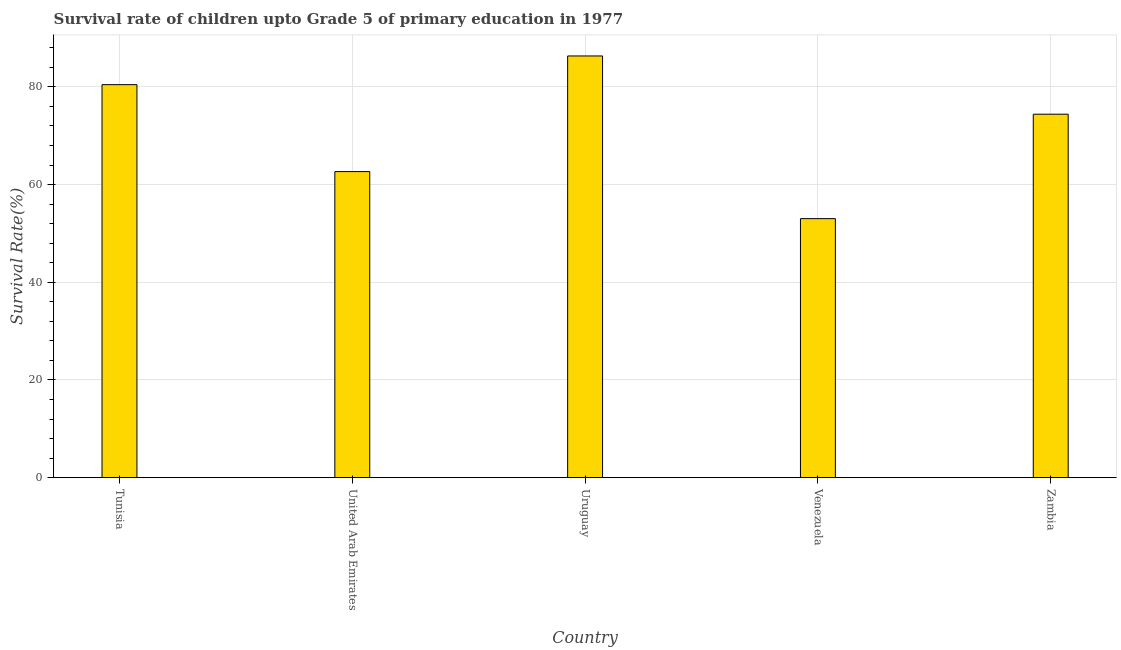What is the title of the graph?
Provide a succinct answer. Survival rate of children upto Grade 5 of primary education in 1977 . What is the label or title of the Y-axis?
Provide a short and direct response. Survival Rate(%). What is the survival rate in Uruguay?
Your answer should be compact. 86.34. Across all countries, what is the maximum survival rate?
Make the answer very short. 86.34. Across all countries, what is the minimum survival rate?
Offer a terse response. 53.03. In which country was the survival rate maximum?
Provide a short and direct response. Uruguay. In which country was the survival rate minimum?
Ensure brevity in your answer.  Venezuela. What is the sum of the survival rate?
Your answer should be compact. 356.92. What is the difference between the survival rate in Tunisia and Uruguay?
Offer a very short reply. -5.88. What is the average survival rate per country?
Keep it short and to the point. 71.38. What is the median survival rate?
Keep it short and to the point. 74.42. In how many countries, is the survival rate greater than 60 %?
Provide a short and direct response. 4. What is the ratio of the survival rate in Uruguay to that in Venezuela?
Make the answer very short. 1.63. Is the survival rate in Tunisia less than that in Zambia?
Offer a terse response. No. Is the difference between the survival rate in United Arab Emirates and Zambia greater than the difference between any two countries?
Offer a terse response. No. What is the difference between the highest and the second highest survival rate?
Make the answer very short. 5.88. Is the sum of the survival rate in United Arab Emirates and Venezuela greater than the maximum survival rate across all countries?
Your answer should be compact. Yes. What is the difference between the highest and the lowest survival rate?
Your answer should be compact. 33.31. How many countries are there in the graph?
Make the answer very short. 5. What is the difference between two consecutive major ticks on the Y-axis?
Your answer should be compact. 20. Are the values on the major ticks of Y-axis written in scientific E-notation?
Keep it short and to the point. No. What is the Survival Rate(%) of Tunisia?
Your response must be concise. 80.46. What is the Survival Rate(%) of United Arab Emirates?
Ensure brevity in your answer.  62.67. What is the Survival Rate(%) of Uruguay?
Make the answer very short. 86.34. What is the Survival Rate(%) in Venezuela?
Make the answer very short. 53.03. What is the Survival Rate(%) of Zambia?
Ensure brevity in your answer.  74.42. What is the difference between the Survival Rate(%) in Tunisia and United Arab Emirates?
Ensure brevity in your answer.  17.8. What is the difference between the Survival Rate(%) in Tunisia and Uruguay?
Make the answer very short. -5.88. What is the difference between the Survival Rate(%) in Tunisia and Venezuela?
Your answer should be compact. 27.43. What is the difference between the Survival Rate(%) in Tunisia and Zambia?
Your answer should be very brief. 6.05. What is the difference between the Survival Rate(%) in United Arab Emirates and Uruguay?
Offer a very short reply. -23.67. What is the difference between the Survival Rate(%) in United Arab Emirates and Venezuela?
Ensure brevity in your answer.  9.63. What is the difference between the Survival Rate(%) in United Arab Emirates and Zambia?
Keep it short and to the point. -11.75. What is the difference between the Survival Rate(%) in Uruguay and Venezuela?
Provide a succinct answer. 33.31. What is the difference between the Survival Rate(%) in Uruguay and Zambia?
Provide a succinct answer. 11.92. What is the difference between the Survival Rate(%) in Venezuela and Zambia?
Your answer should be compact. -21.39. What is the ratio of the Survival Rate(%) in Tunisia to that in United Arab Emirates?
Keep it short and to the point. 1.28. What is the ratio of the Survival Rate(%) in Tunisia to that in Uruguay?
Your answer should be compact. 0.93. What is the ratio of the Survival Rate(%) in Tunisia to that in Venezuela?
Offer a terse response. 1.52. What is the ratio of the Survival Rate(%) in Tunisia to that in Zambia?
Keep it short and to the point. 1.08. What is the ratio of the Survival Rate(%) in United Arab Emirates to that in Uruguay?
Provide a succinct answer. 0.73. What is the ratio of the Survival Rate(%) in United Arab Emirates to that in Venezuela?
Your answer should be very brief. 1.18. What is the ratio of the Survival Rate(%) in United Arab Emirates to that in Zambia?
Make the answer very short. 0.84. What is the ratio of the Survival Rate(%) in Uruguay to that in Venezuela?
Keep it short and to the point. 1.63. What is the ratio of the Survival Rate(%) in Uruguay to that in Zambia?
Keep it short and to the point. 1.16. What is the ratio of the Survival Rate(%) in Venezuela to that in Zambia?
Your answer should be compact. 0.71. 